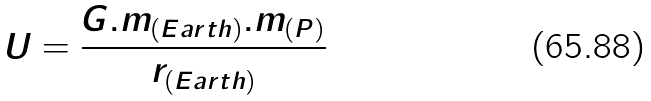Convert formula to latex. <formula><loc_0><loc_0><loc_500><loc_500>U = { \frac { { G . m _ { ( E a r t h ) } . m _ { ( P ) } } } { { r _ { ( E a r t h ) } } } }</formula> 